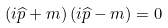<formula> <loc_0><loc_0><loc_500><loc_500>\left ( i \widehat { p } + m \right ) \left ( i \widehat { p } - m \right ) = 0</formula> 